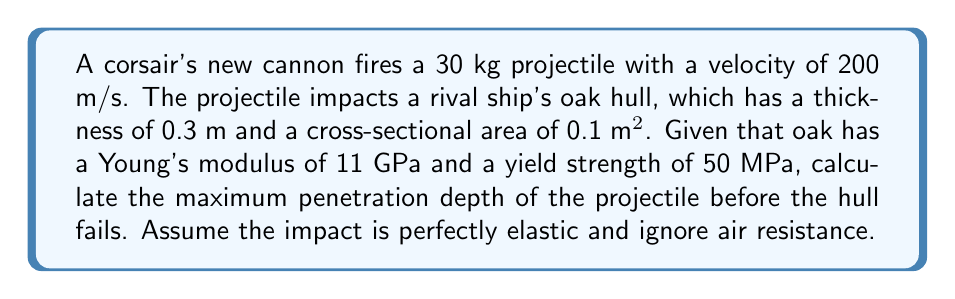Help me with this question. To solve this problem, we'll use the concepts of energy, stress, and strain.

Step 1: Calculate the kinetic energy of the projectile
$$E_k = \frac{1}{2}mv^2 = \frac{1}{2} \cdot 30 \text{ kg} \cdot (200 \text{ m/s})^2 = 600,000 \text{ J}$$

Step 2: Use the work-energy principle to relate energy to force and displacement
$$W = F \cdot d = E_k$$
where $F$ is the average force and $d$ is the penetration depth.

Step 3: Express force in terms of stress
$$F = \sigma \cdot A$$
where $\sigma$ is stress and $A$ is the cross-sectional area.

Step 4: Use Hooke's law to relate stress and strain
$$\sigma = E \cdot \varepsilon$$
where $E$ is Young's modulus and $\varepsilon$ is strain.

Step 5: Express strain in terms of penetration depth
$$\varepsilon = \frac{d}{L}$$
where $L$ is the hull thickness.

Step 6: Combine equations from steps 2-5
$$600,000 \text{ J} = (E \cdot \frac{d}{L} \cdot A) \cdot d$$

Step 7: Solve for $d$
$$d = \sqrt{\frac{600,000 \text{ J} \cdot L}{E \cdot A}} = \sqrt{\frac{600,000 \text{ J} \cdot 0.3 \text{ m}}{11 \cdot 10^9 \text{ Pa} \cdot 0.1 \text{ m}^2}} = 0.1125 \text{ m}$$

Step 8: Check if this depth causes failure
Maximum stress: $$\sigma_{max} = E \cdot \frac{d}{L} = 11 \cdot 10^9 \text{ Pa} \cdot \frac{0.1125 \text{ m}}{0.3 \text{ m}} = 4.125 \cdot 10^9 \text{ Pa}$$

This stress (4.125 GPa) exceeds the yield strength (50 MPa), so the hull will fail before reaching this depth.

Step 9: Calculate the actual penetration depth at failure
$$d_{fail} = \frac{\sigma_{yield} \cdot L}{E} = \frac{50 \cdot 10^6 \text{ Pa} \cdot 0.3 \text{ m}}{11 \cdot 10^9 \text{ Pa}} = 0.001364 \text{ m}$$
Answer: 0.001364 m 